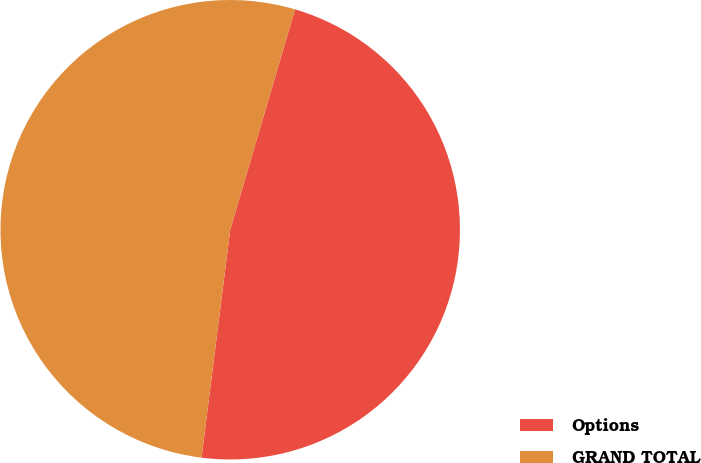Convert chart to OTSL. <chart><loc_0><loc_0><loc_500><loc_500><pie_chart><fcel>Options<fcel>GRAND TOTAL<nl><fcel>47.44%<fcel>52.56%<nl></chart> 